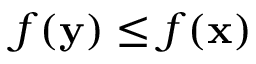<formula> <loc_0><loc_0><loc_500><loc_500>f ( y ) \leq f ( x )</formula> 